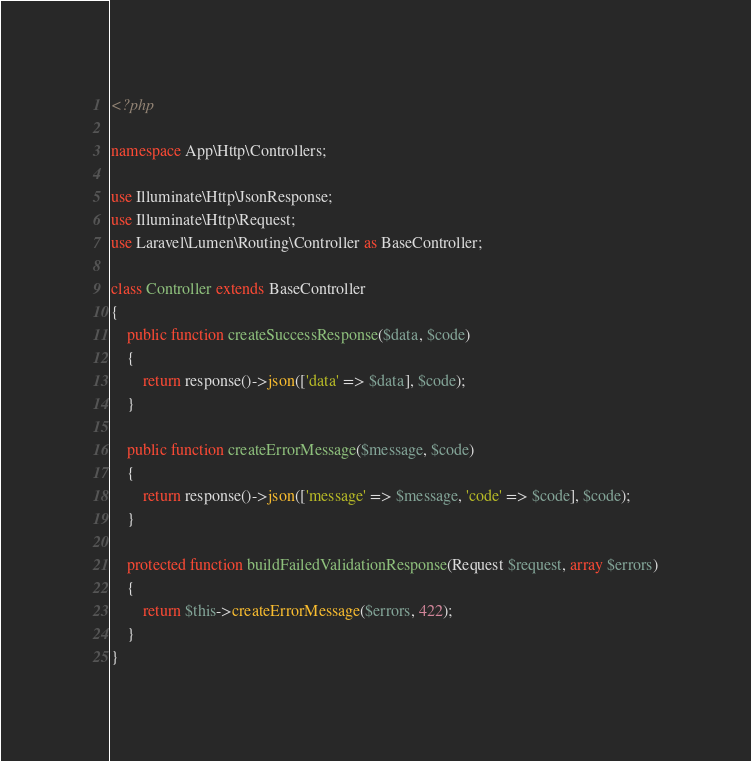Convert code to text. <code><loc_0><loc_0><loc_500><loc_500><_PHP_><?php

namespace App\Http\Controllers;

use Illuminate\Http\JsonResponse;
use Illuminate\Http\Request;
use Laravel\Lumen\Routing\Controller as BaseController;

class Controller extends BaseController
{
    public function createSuccessResponse($data, $code)
    {
        return response()->json(['data' => $data], $code);
    }

    public function createErrorMessage($message, $code)
    {
        return response()->json(['message' => $message, 'code' => $code], $code);
    }

    protected function buildFailedValidationResponse(Request $request, array $errors)
    {
        return $this->createErrorMessage($errors, 422);
    }
}
</code> 